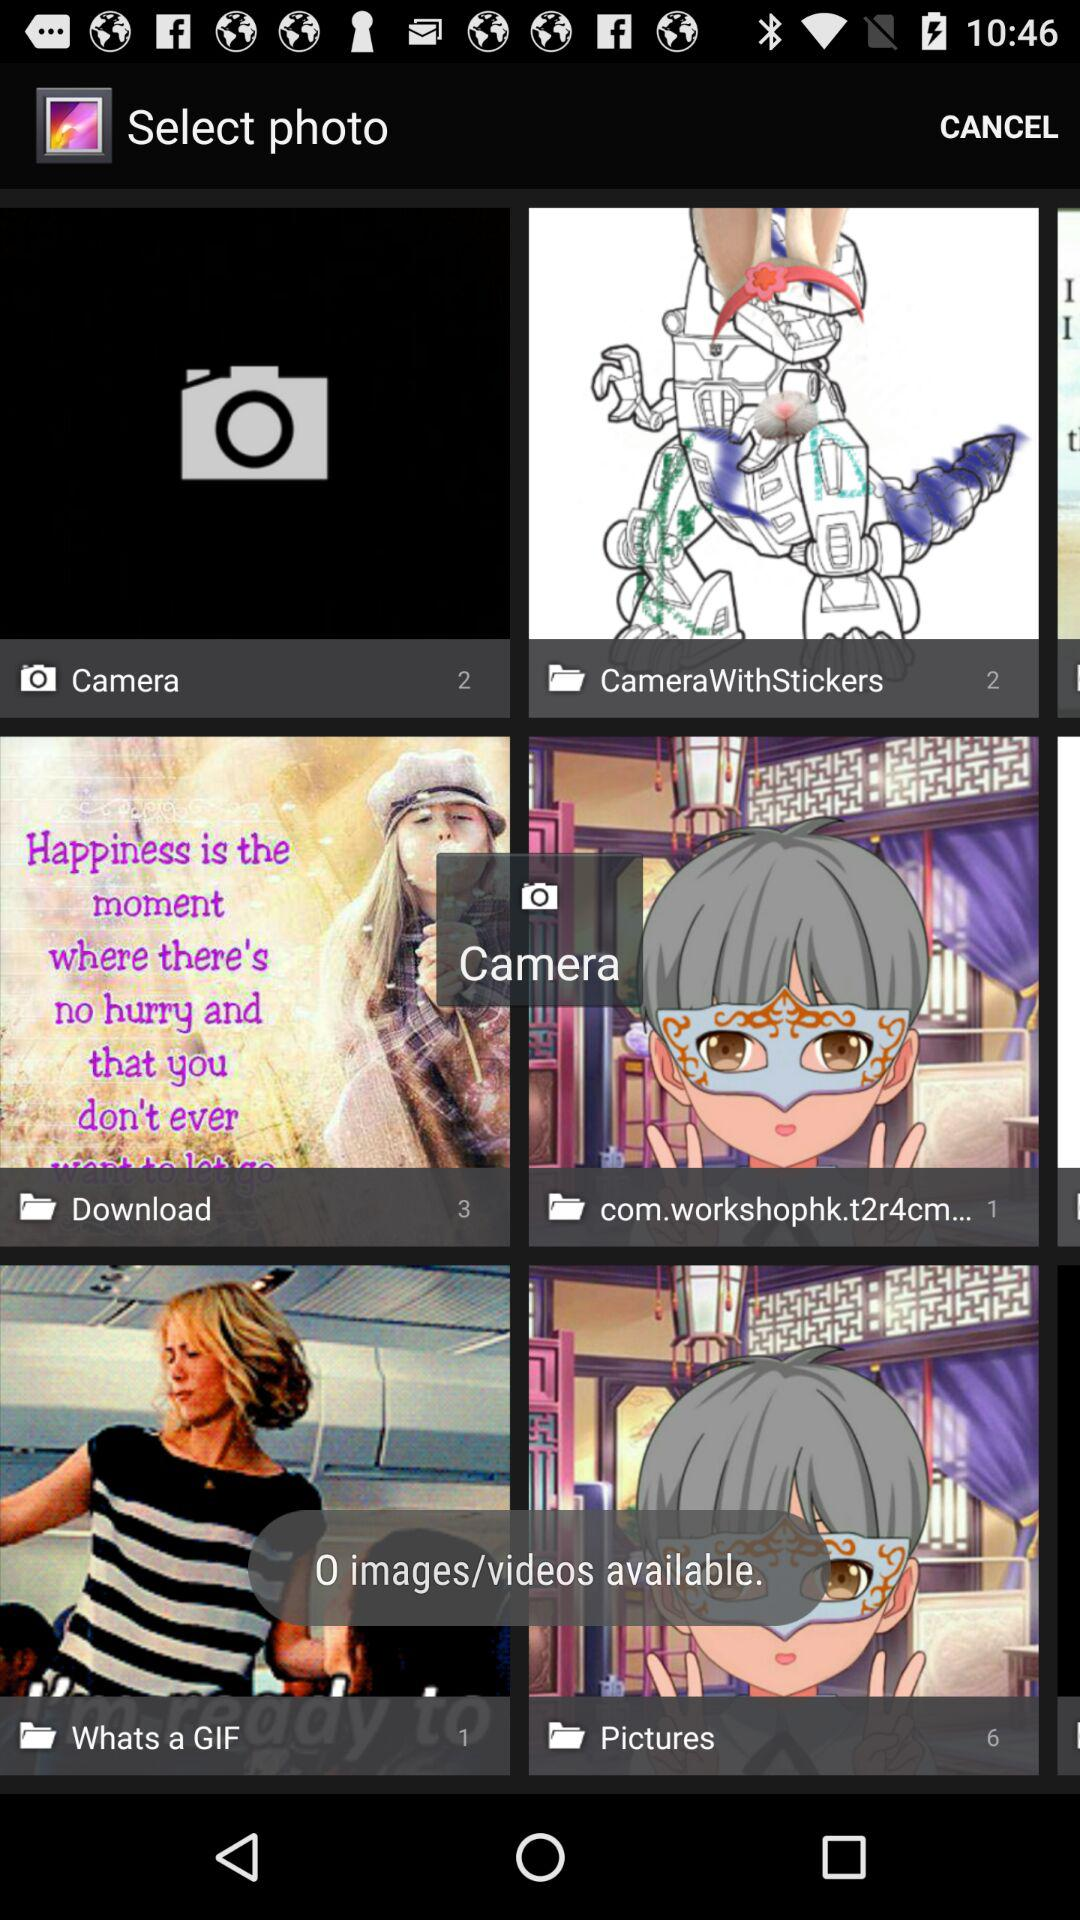How many pictures are in the "Camera" folder? There are 2 pictures in the "Camera" folder. 